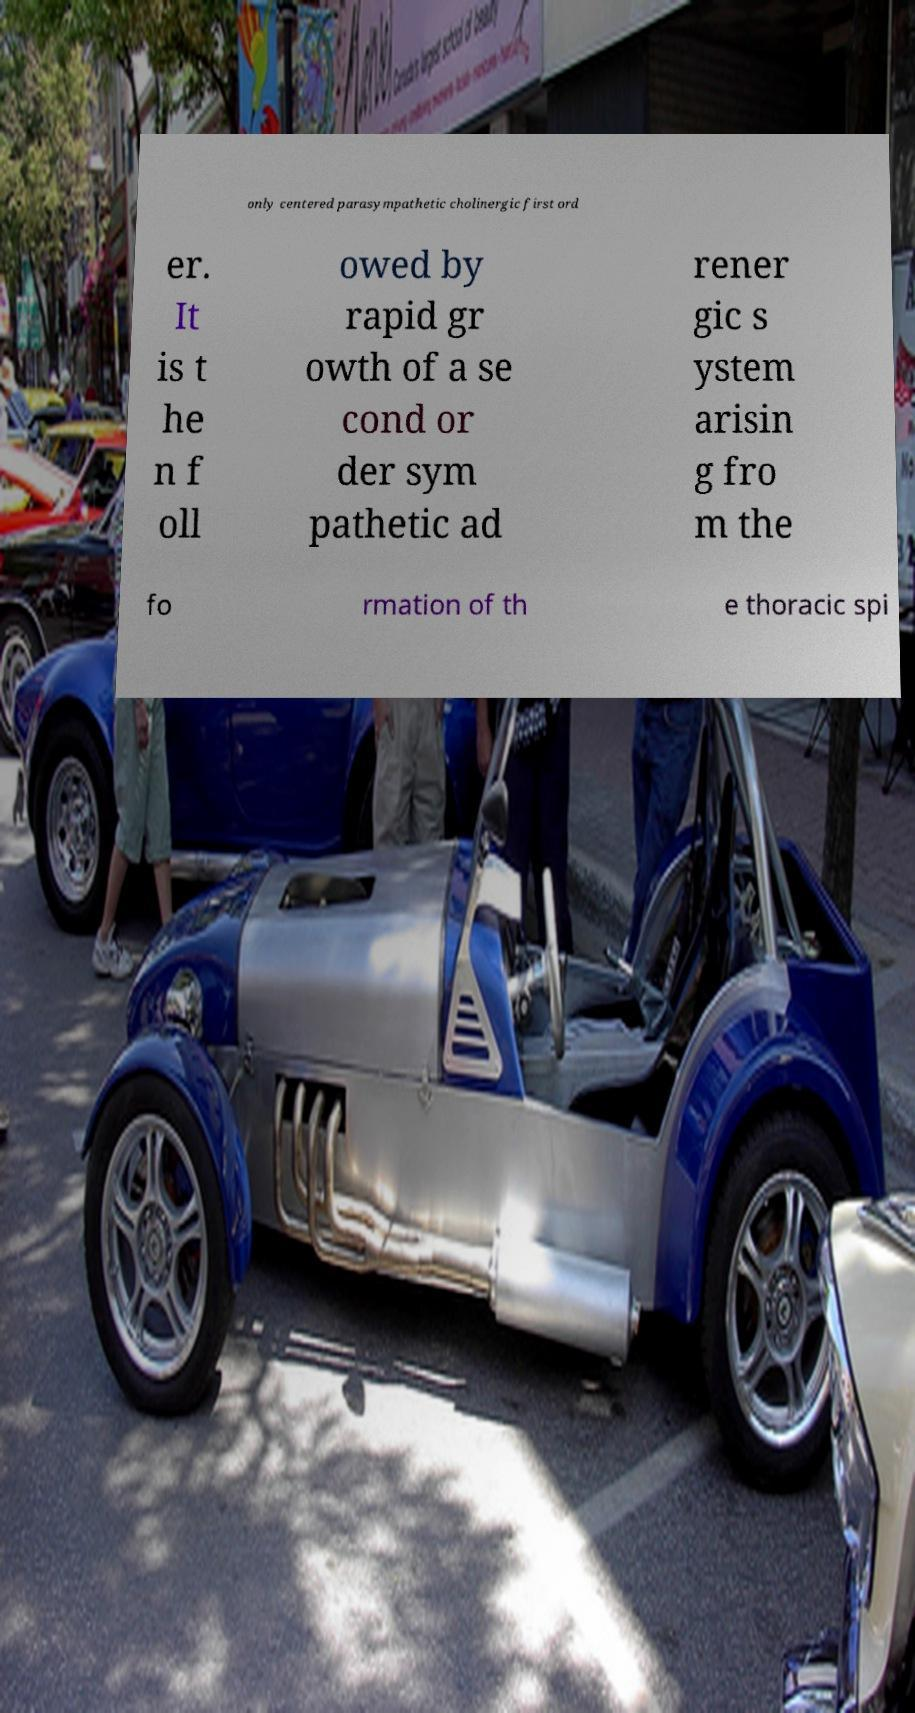Could you extract and type out the text from this image? only centered parasympathetic cholinergic first ord er. It is t he n f oll owed by rapid gr owth of a se cond or der sym pathetic ad rener gic s ystem arisin g fro m the fo rmation of th e thoracic spi 